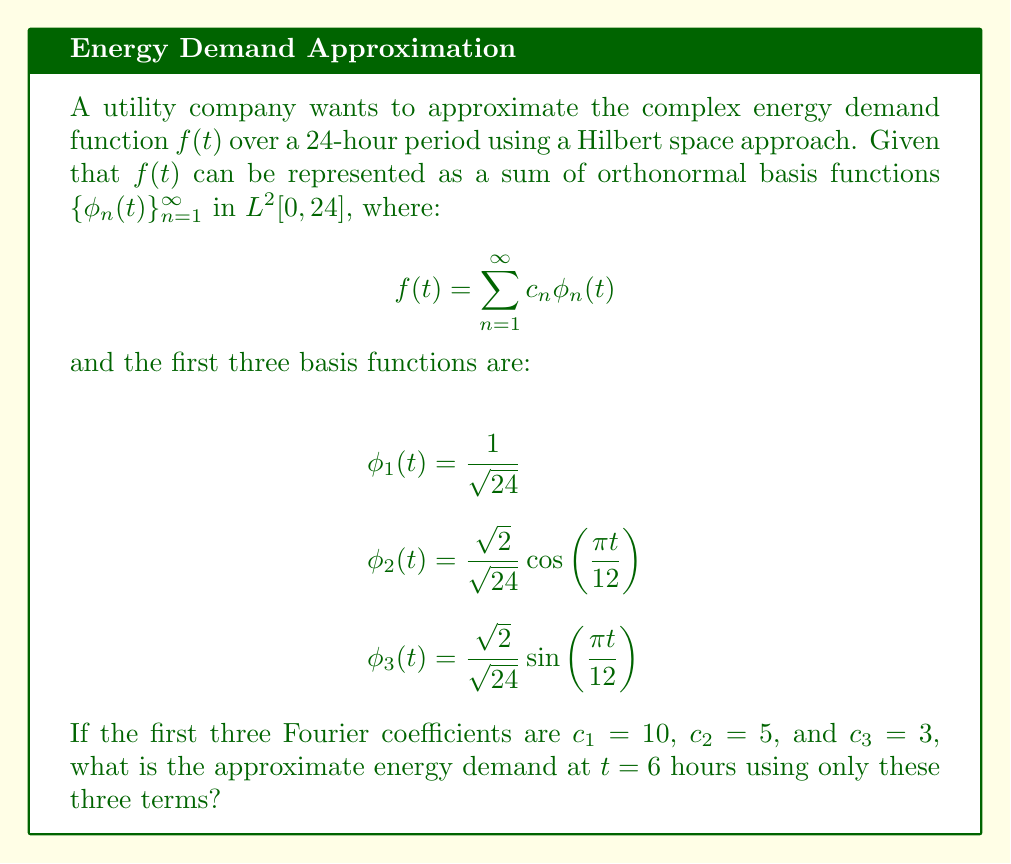Could you help me with this problem? To solve this problem, we'll follow these steps:

1) Recall that the approximation of $f(t)$ using the first three terms is:

   $$f(t) \approx c_1\phi_1(t) + c_2\phi_2(t) + c_3\phi_3(t)$$

2) We're given the values of $c_1$, $c_2$, and $c_3$, so let's substitute these:

   $$f(t) \approx 10\phi_1(t) + 5\phi_2(t) + 3\phi_3(t)$$

3) Now, let's substitute the expressions for $\phi_1(t)$, $\phi_2(t)$, and $\phi_3(t)$:

   $$f(t) \approx 10 \cdot \frac{1}{\sqrt{24}} + 5 \cdot \frac{\sqrt{2}}{\sqrt{24}} \cos\left(\frac{\pi t}{12}\right) + 3 \cdot \frac{\sqrt{2}}{\sqrt{24}} \sin\left(\frac{\pi t}{12}\right)$$

4) We want to find $f(6)$, so let's substitute $t = 6$:

   $$f(6) \approx 10 \cdot \frac{1}{\sqrt{24}} + 5 \cdot \frac{\sqrt{2}}{\sqrt{24}} \cos\left(\frac{\pi \cdot 6}{12}\right) + 3 \cdot \frac{\sqrt{2}}{\sqrt{24}} \sin\left(\frac{\pi \cdot 6}{12}\right)$$

5) Simplify the trigonometric terms:
   
   $\cos(\frac{\pi}{2}) = 0$ and $\sin(\frac{\pi}{2}) = 1$

   $$f(6) \approx 10 \cdot \frac{1}{\sqrt{24}} + 5 \cdot \frac{\sqrt{2}}{\sqrt{24}} \cdot 0 + 3 \cdot \frac{\sqrt{2}}{\sqrt{24}} \cdot 1$$

6) Simplify:

   $$f(6) \approx \frac{10}{\sqrt{24}} + \frac{3\sqrt{2}}{\sqrt{24}}$$

7) Combine terms under a common denominator:

   $$f(6) \approx \frac{10 + 3\sqrt{2}}{\sqrt{24}}$$

This is our final approximation of the energy demand at $t = 6$ hours.
Answer: $\frac{10 + 3\sqrt{2}}{\sqrt{24}}$ 